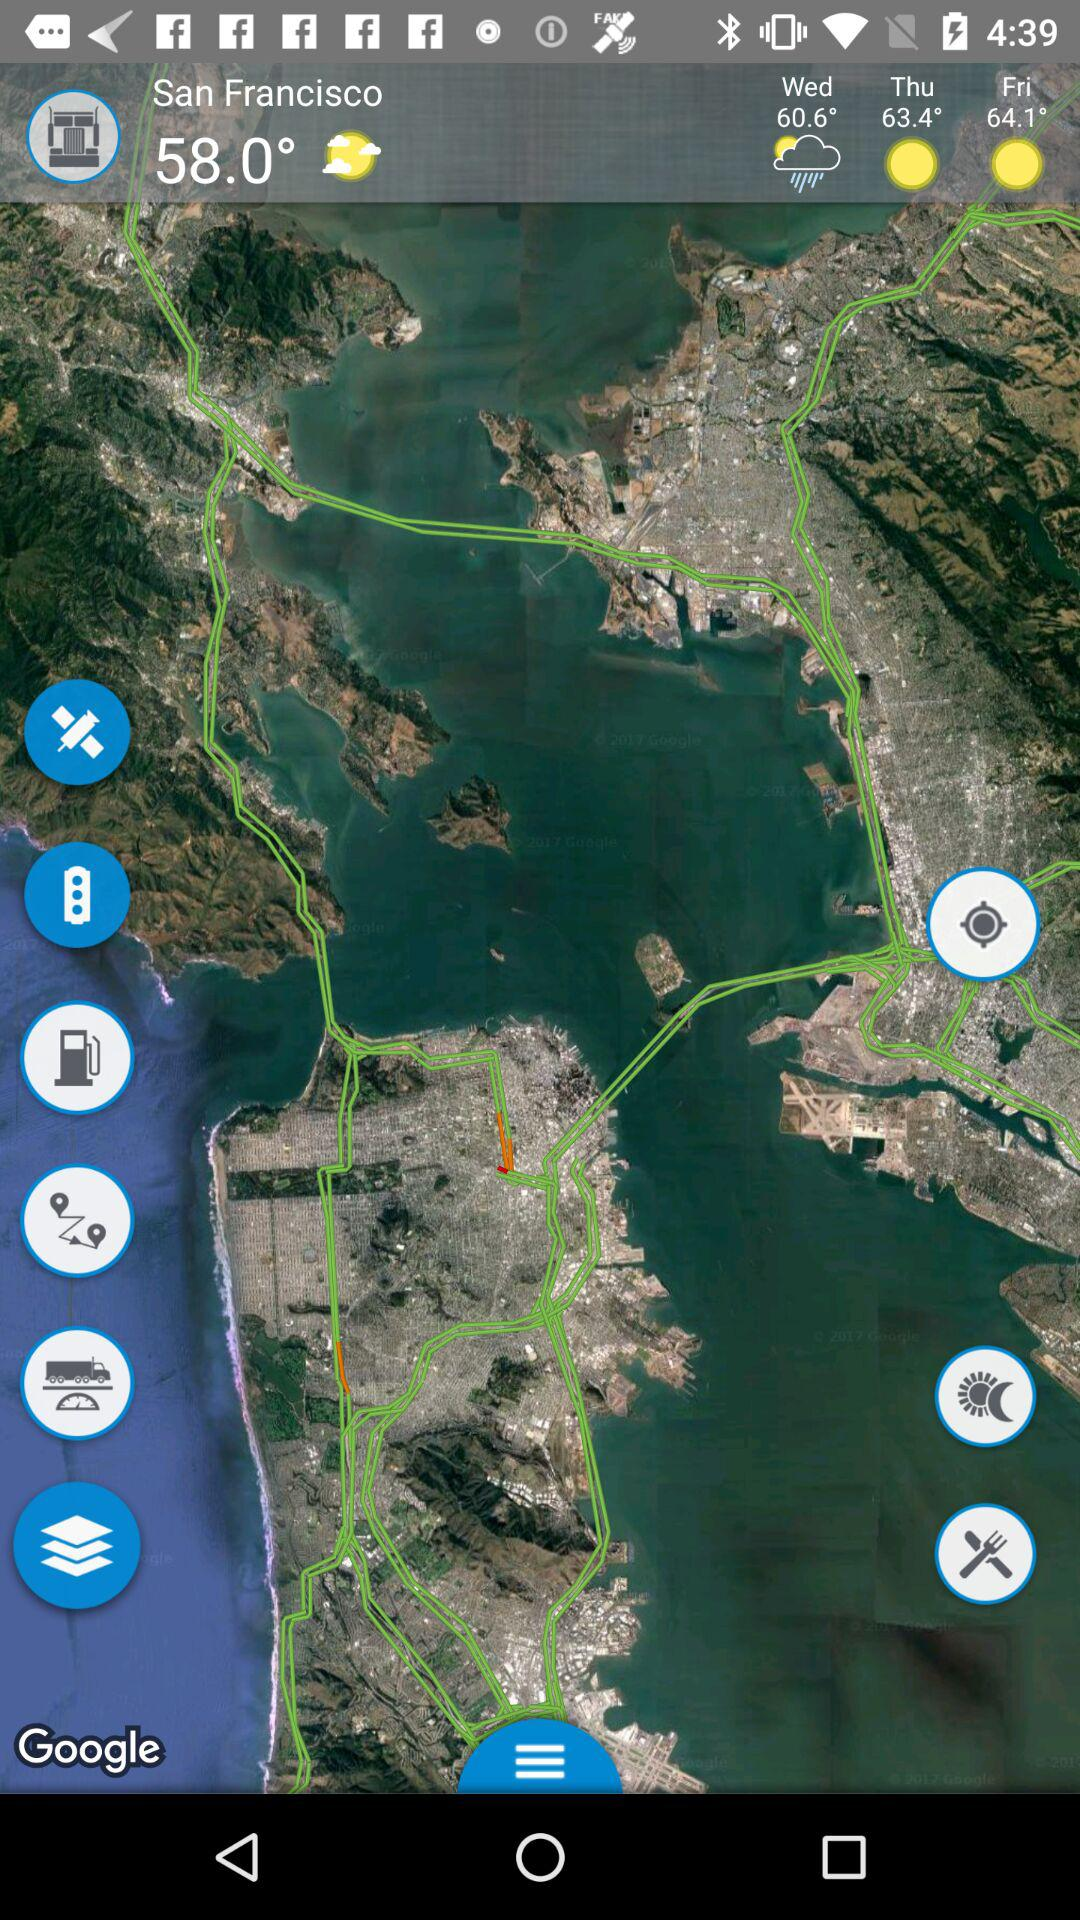What will be the temperature on Friday? The temperature on Friday will be 64.1°. 